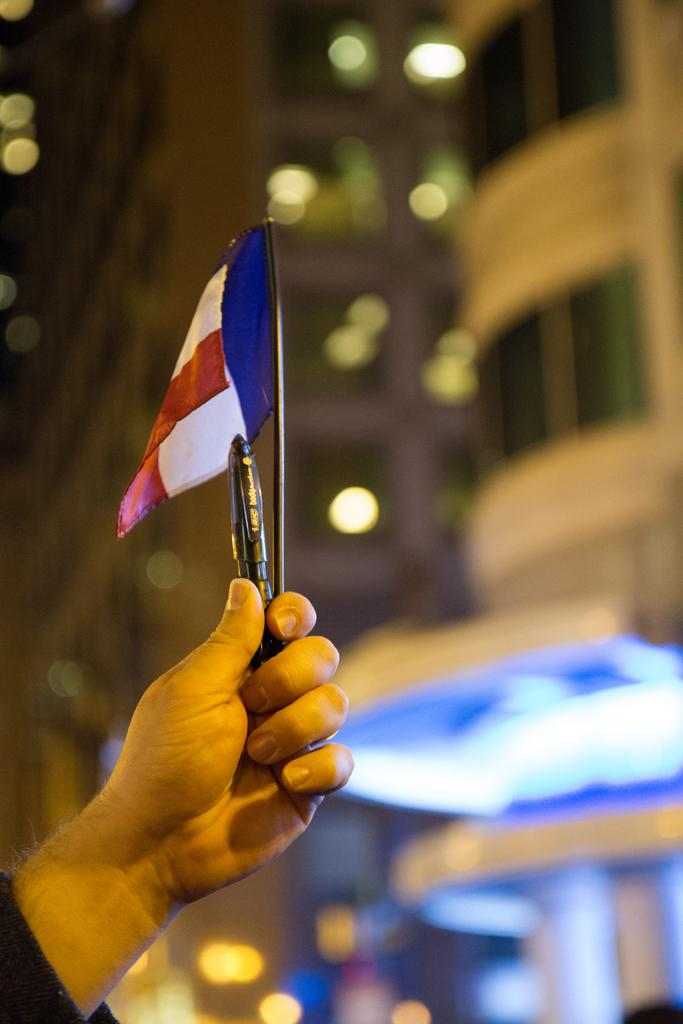What is being held in the foreground of the image? There is a person's hand holding a flag in the foreground of the image. What else can be seen in the person's hand? There is a pen in the person's hand. What can be seen in the background of the image? There are buildings in the background of the image. What type of industry can be seen on the side of the buildings in the image? There is no specific industry mentioned or visible in the image; it only shows buildings in the background. 